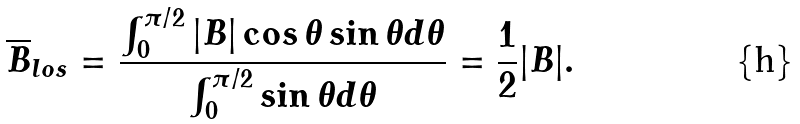<formula> <loc_0><loc_0><loc_500><loc_500>\overline { B } _ { l o s } = \frac { \int _ { 0 } ^ { \pi / 2 } | { B } | \cos \theta \sin \theta d \theta } { \int _ { 0 } ^ { \pi / 2 } \sin \theta d \theta } = \frac { 1 } { 2 } | { B } | .</formula> 